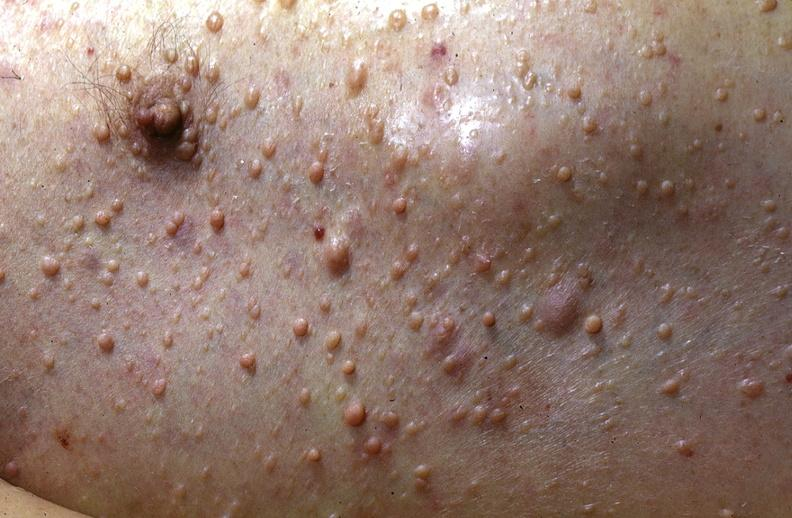does small intestine show skin, neurofibromatosis?
Answer the question using a single word or phrase. No 